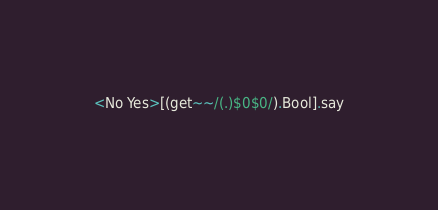<code> <loc_0><loc_0><loc_500><loc_500><_Perl_><No Yes>[(get~~/(.)$0$0/).Bool].say</code> 